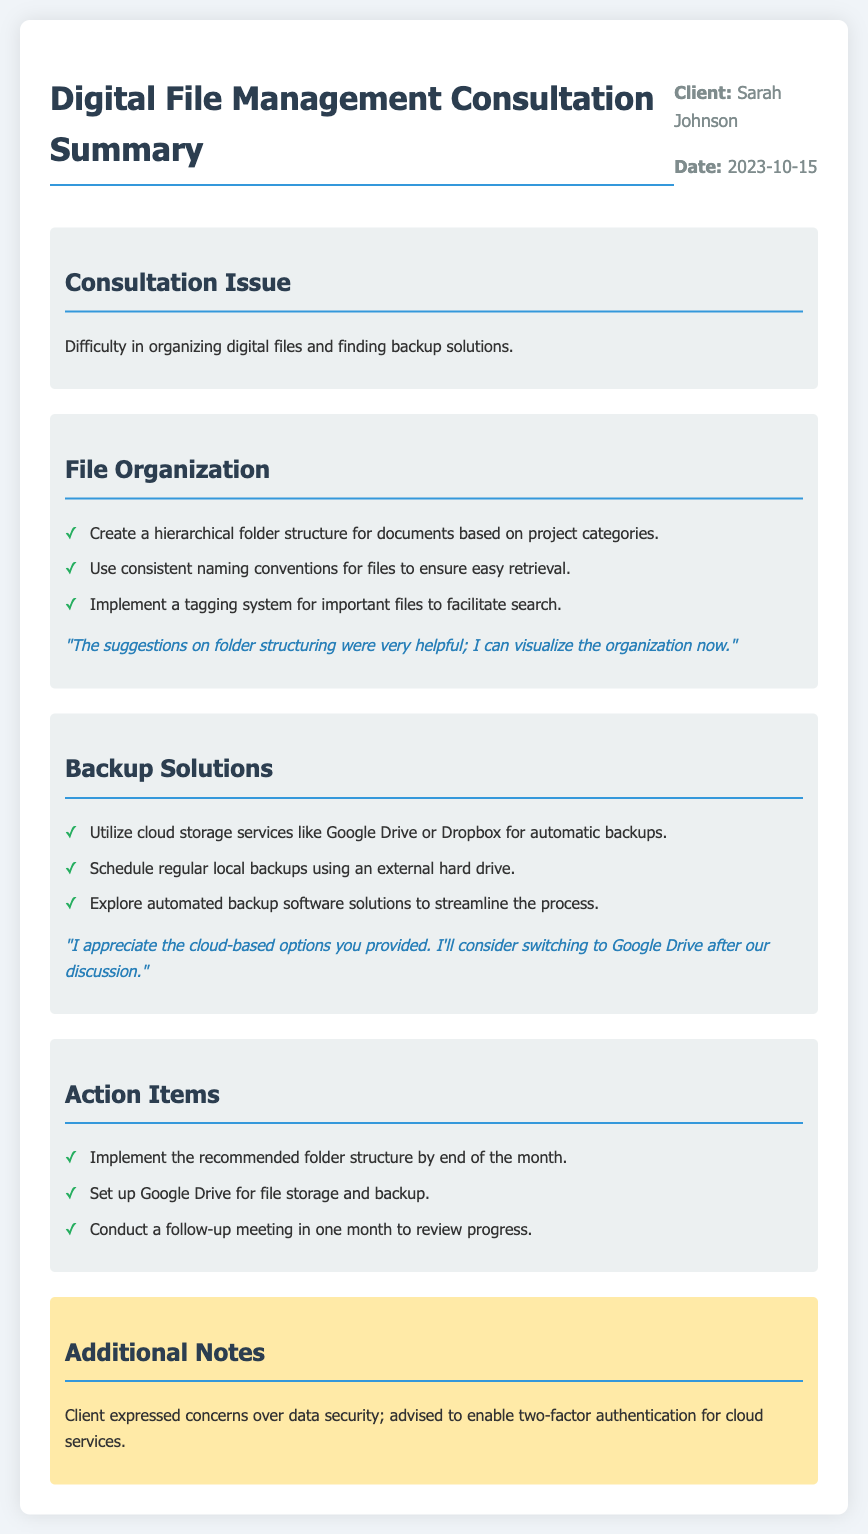What is the client's name? The client's name is mentioned at the top of the document under client info.
Answer: Sarah Johnson What is the consultation issue? The issue is stated in the "Consultation Issue" section of the document.
Answer: Difficulty in organizing digital files and finding backup solutions What is one recommended backup solution? The document lists several backup solutions in the "Backup Solutions" section.
Answer: Utilize cloud storage services like Google Drive or Dropbox for automatic backups When is the follow-up meeting scheduled? The follow-up meeting is mentioned in the "Action Items" section of the document.
Answer: In one month What concern did the client express? The client's concern is noted in the "Additional Notes" section.
Answer: Data security How many recommendations are there for file organization? The number of recommendations is counted in the "File Organization" section.
Answer: Three What feedback did the client provide about folder structuring? The feedback is provided right after the recommendations in the "File Organization" section.
Answer: The suggestions on folder structuring were very helpful; I can visualize the organization now Which cloud service did the client consider switching to? This information is found in the feedback given after the backup solutions recommendations.
Answer: Google Drive 